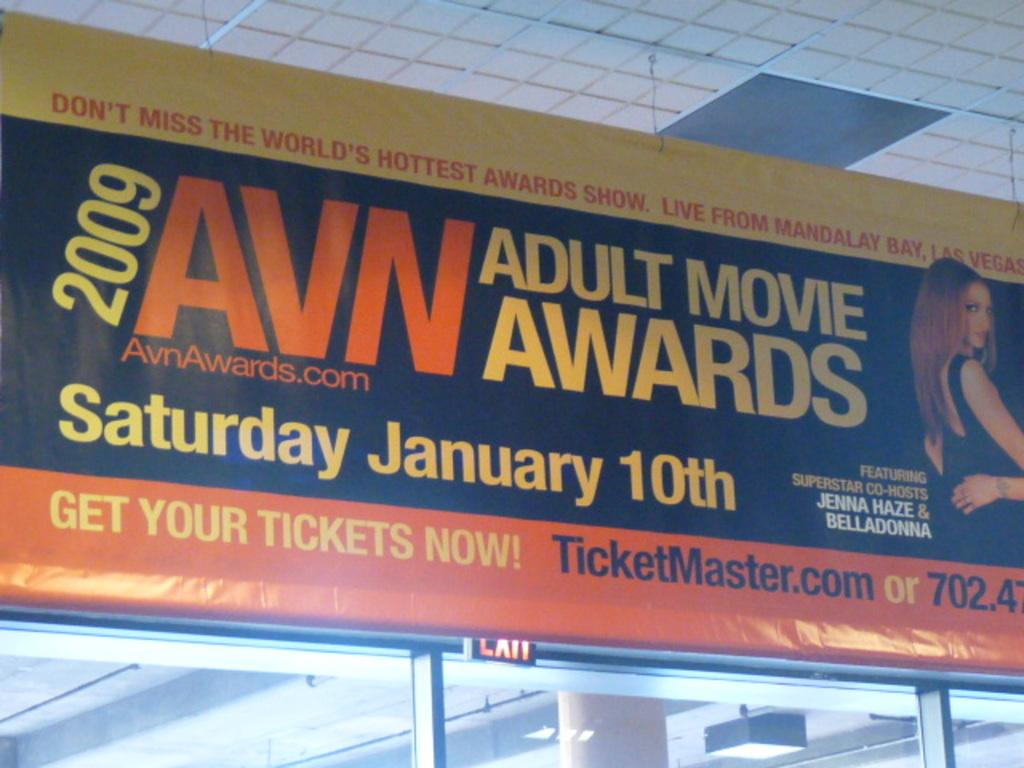What is located in the middle of the image? There is a banner in the middle of the image. What object can be seen at the bottom of the image? There is a glass at the bottom of the image. What part of a building is visible at the top of the image? The roof is visible at the top of the image. How does the banner aid in the digestion process in the image? The banner does not aid in the digestion process, as it is an inanimate object and not related to digestion. What type of ice is present in the image? There is no ice present in the image. 